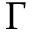Convert formula to latex. <formula><loc_0><loc_0><loc_500><loc_500>\Gamma</formula> 